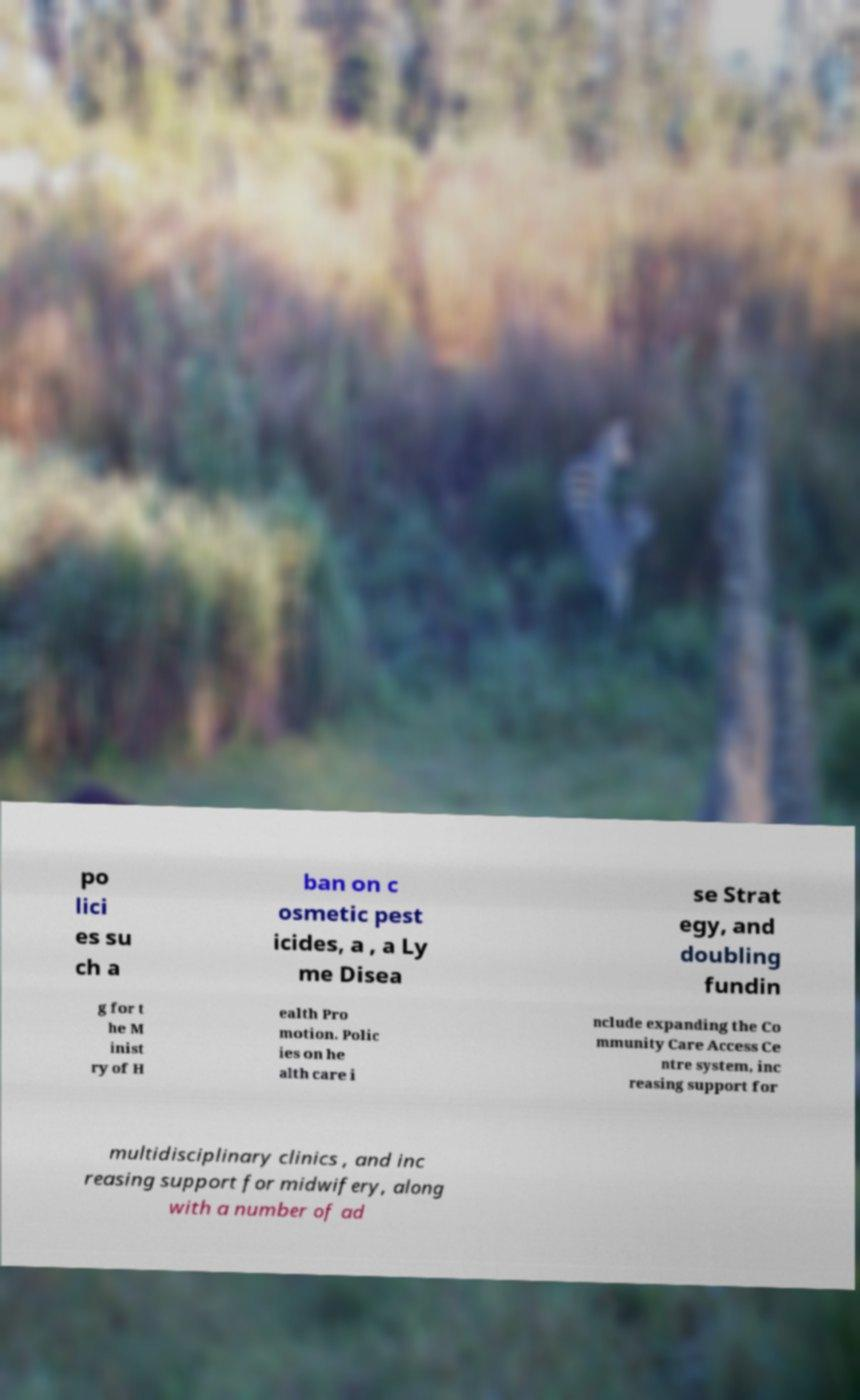What messages or text are displayed in this image? I need them in a readable, typed format. po lici es su ch a ban on c osmetic pest icides, a , a Ly me Disea se Strat egy, and doubling fundin g for t he M inist ry of H ealth Pro motion. Polic ies on he alth care i nclude expanding the Co mmunity Care Access Ce ntre system, inc reasing support for multidisciplinary clinics , and inc reasing support for midwifery, along with a number of ad 